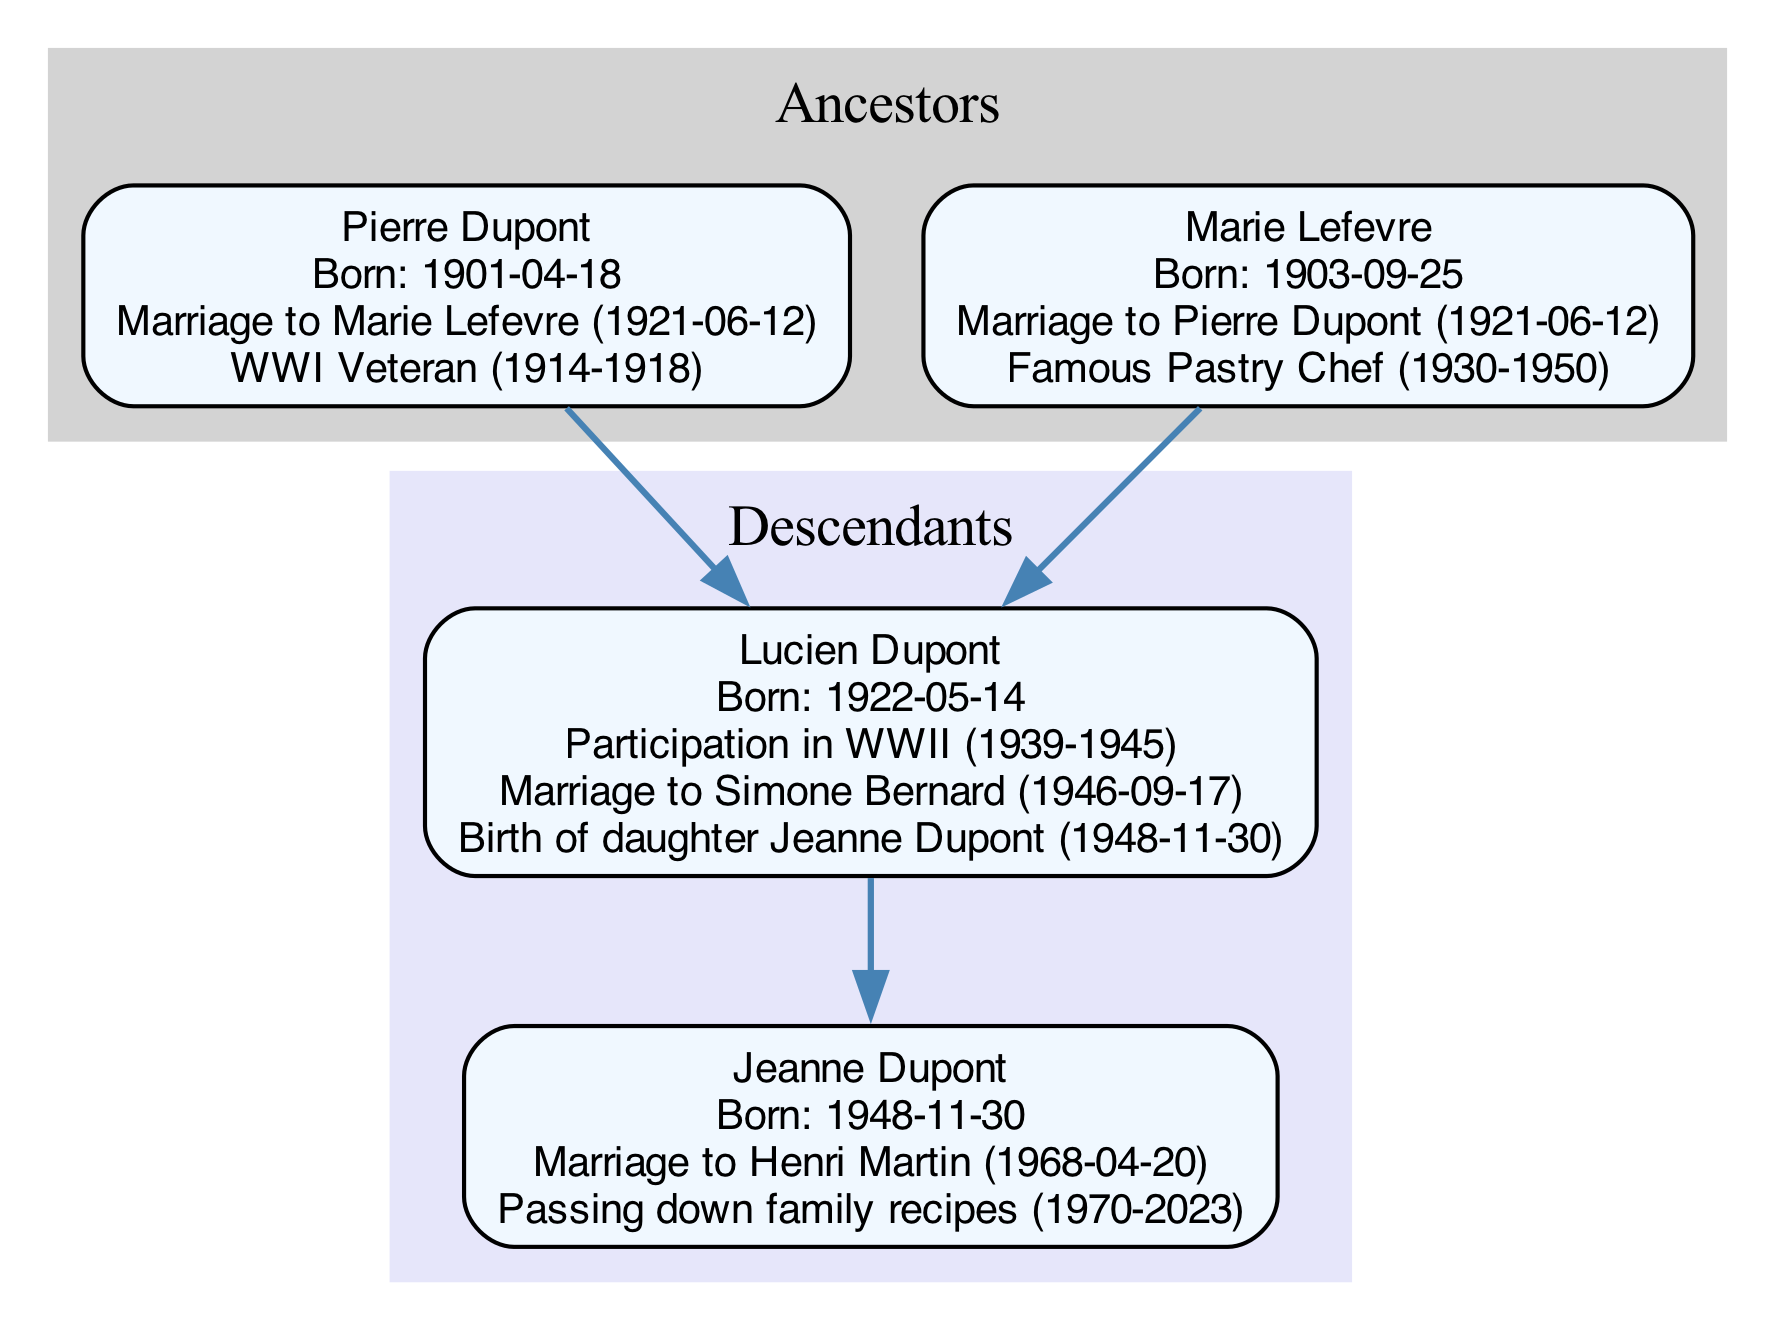What is the birth year of Pierre Dupont? By examining the node for Pierre Dupont in the diagram, we see the label indicates his birth date as April 18, 1901. Therefore, his birth year is 1901.
Answer: 1901 Who did Lucien Dupont marry? Looking at the significant life events listed under Lucien Dupont's node in the diagram, it states that he married Simone Bernard on September 17, 1946.
Answer: Simone Bernard How many significant life events does Jeanne Dupont have? In the node detailing Jeanne Dupont, there are two significant life events listed: her marriage to Henri Martin and her passing down family recipes. Hence, the total count of significant events is two.
Answer: 2 What event did Marie Lefevre accomplish between 1930 and 1950? The diagram shows that Marie Lefevre was a famous pastry chef, and this time span is specified in her significant life events. It directly indicates this achievement during those years.
Answer: Famous Pastry Chef Who is the child of Lucien Dupont? Referring to Lucien Dupont's significant life events, it states that he had a daughter named Jeanne Dupont, which clearly indicates the parent-child relationship.
Answer: Jeanne Dupont Which ancestor was a WWI veteran? The diagram highlights Pierre Dupont's significant life event as being a WWI veteran for the duration of 1914 to 1918, indicating his involvement in the war.
Answer: Pierre Dupont What notable event occurred in 1968 related to Jeanne Dupont? In the diagram, we see that in 1968, Jeanne Dupont got married to Henri Martin, which is a significant event listed under her life.
Answer: Marriage to Henri Martin What is the relationship between Pierre Dupont and Lucien Dupont? The diagram shows a direct connection where Pierre Dupont is the father of Lucien Dupont, indicating a parent-child relationship.
Answer: Father and Son How many ancestors are listed in the family tree? The family tree in the diagram details two ancestors: Pierre Dupont and Marie Lefevre, which clearly counts as a total of two.
Answer: 2 